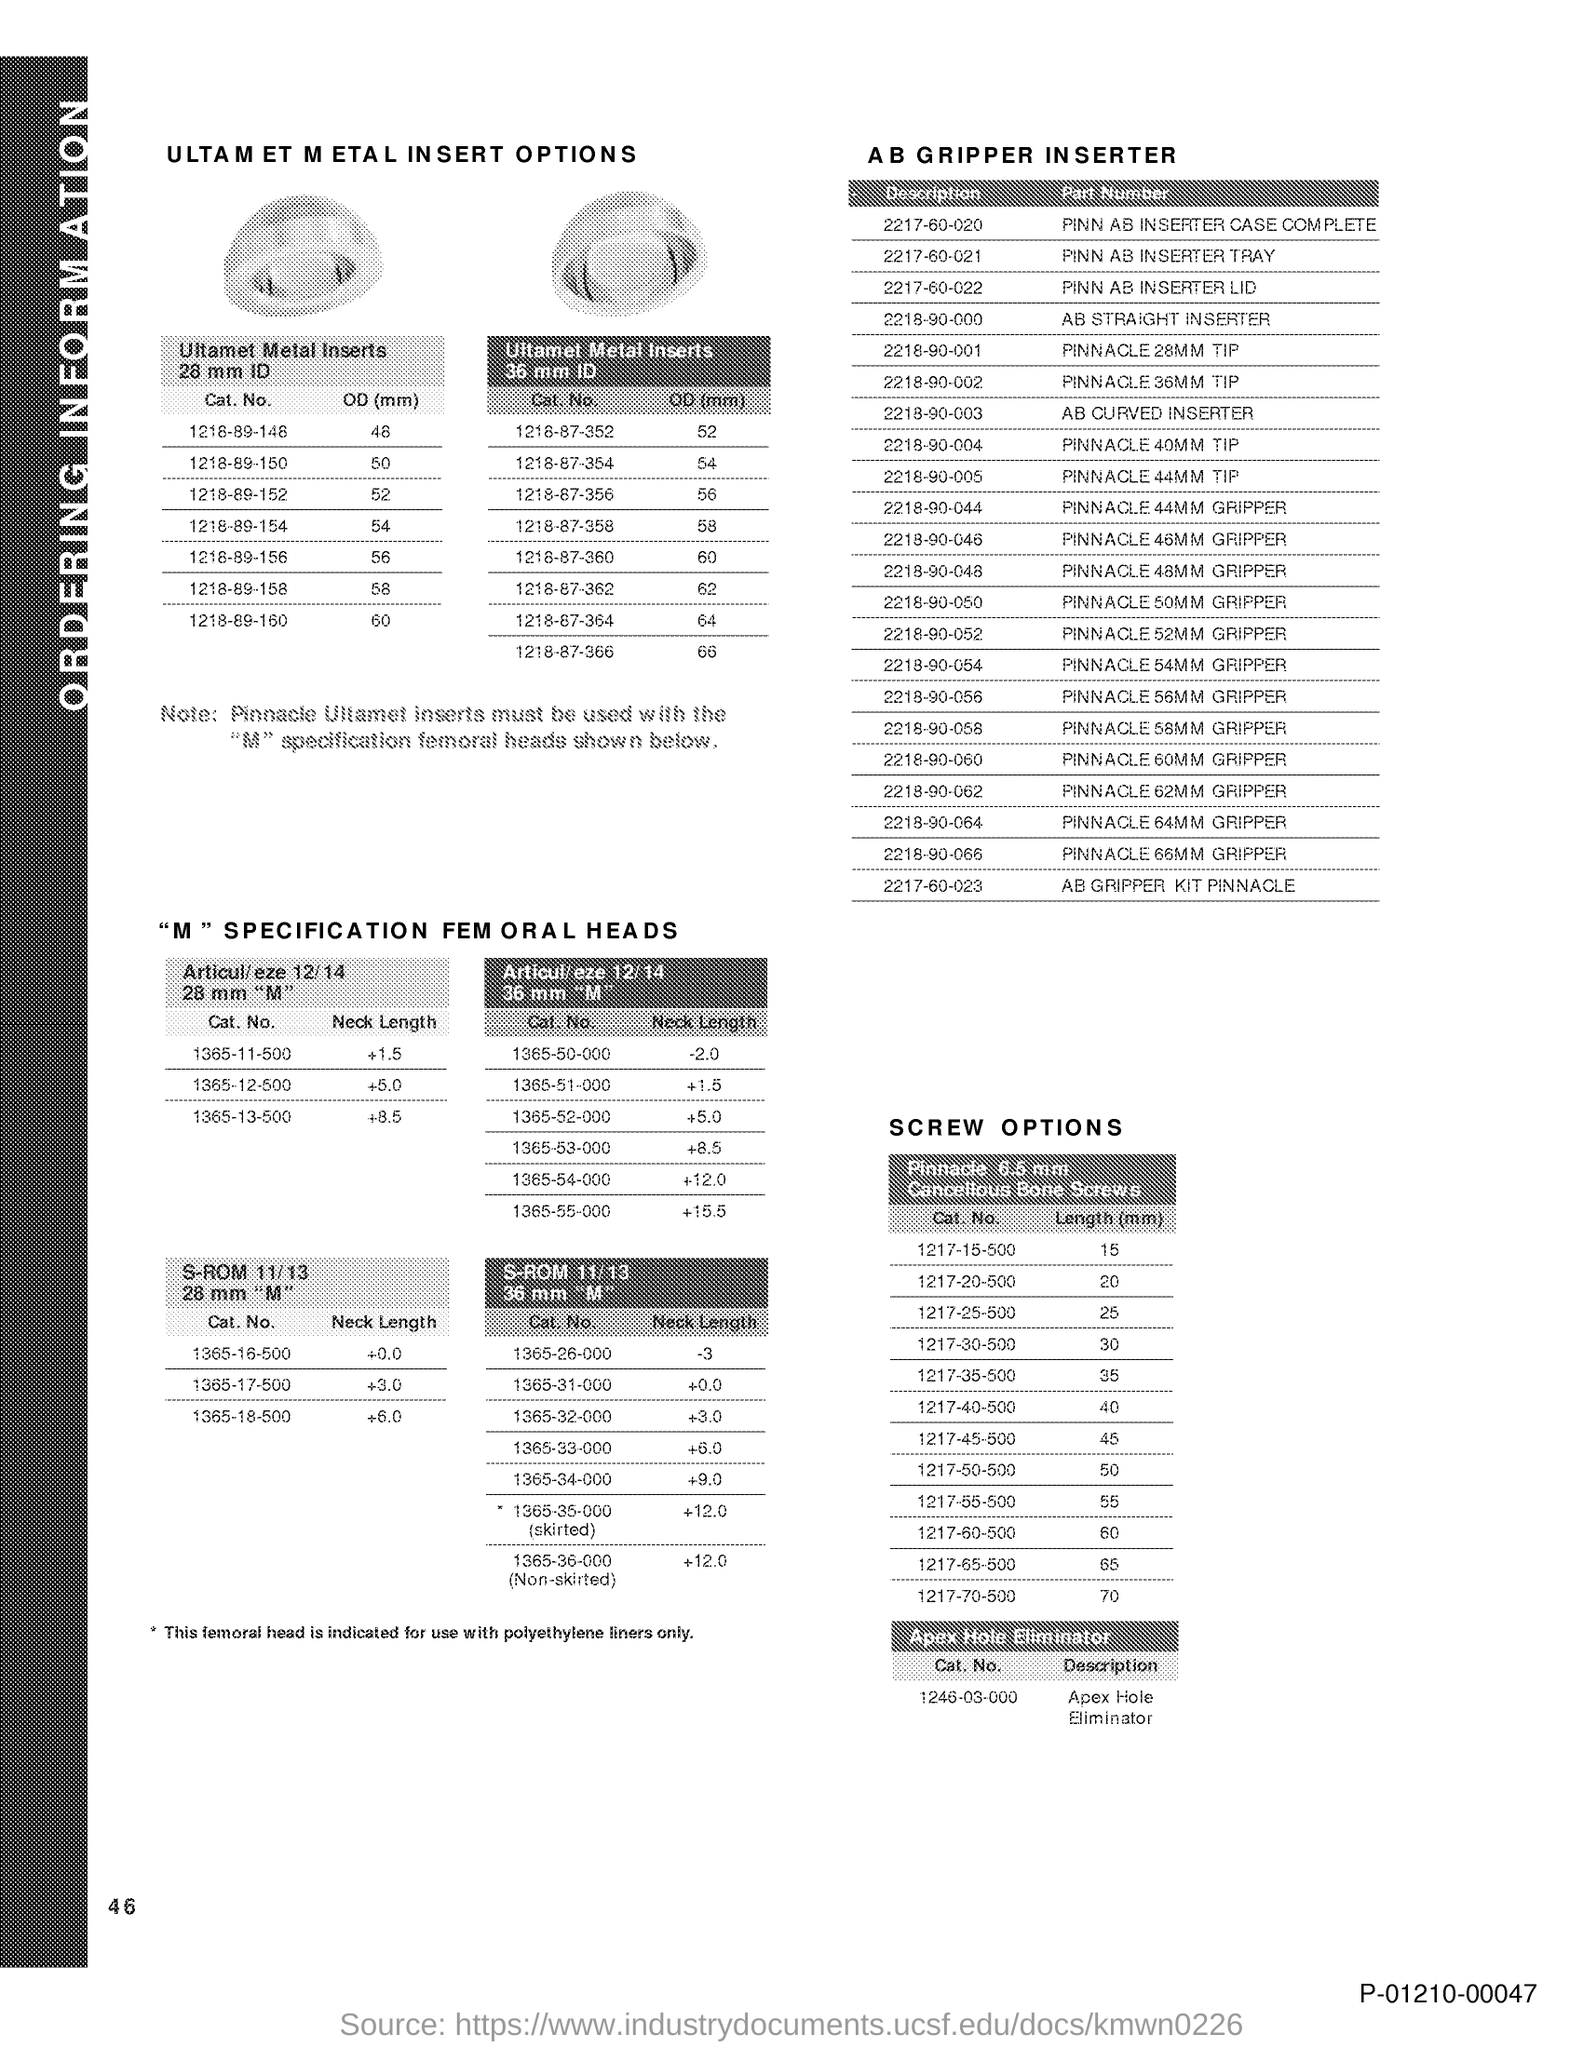What is the length(mm) for cat. no. 1217-15-500 ?
Your answer should be compact. 15. What is the length(mm) for cat. no. 1217-20-500?
Make the answer very short. 20. What is the length(mm) for cat. no. 1217-25-500?
Provide a short and direct response. 25. What is the length(mm) for cat. no. 1217-30-500?
Your response must be concise. 30. What is the length(mm) for cat. no. 1217-35-500?
Offer a very short reply. 35. What is the length(mm) for cat. no. 1217-40-500?
Ensure brevity in your answer.  40. What is the length(mm) for cat. no. 1217-45-500?
Offer a very short reply. 45. What is the length(mm) for cat. no. 1217-50-500?
Keep it short and to the point. 50. What is the length(mm) for cat. no. 1217-55-500?
Keep it short and to the point. 55. What is the length(mm) for cat. no. 1217-60-500?
Your response must be concise. 60. 